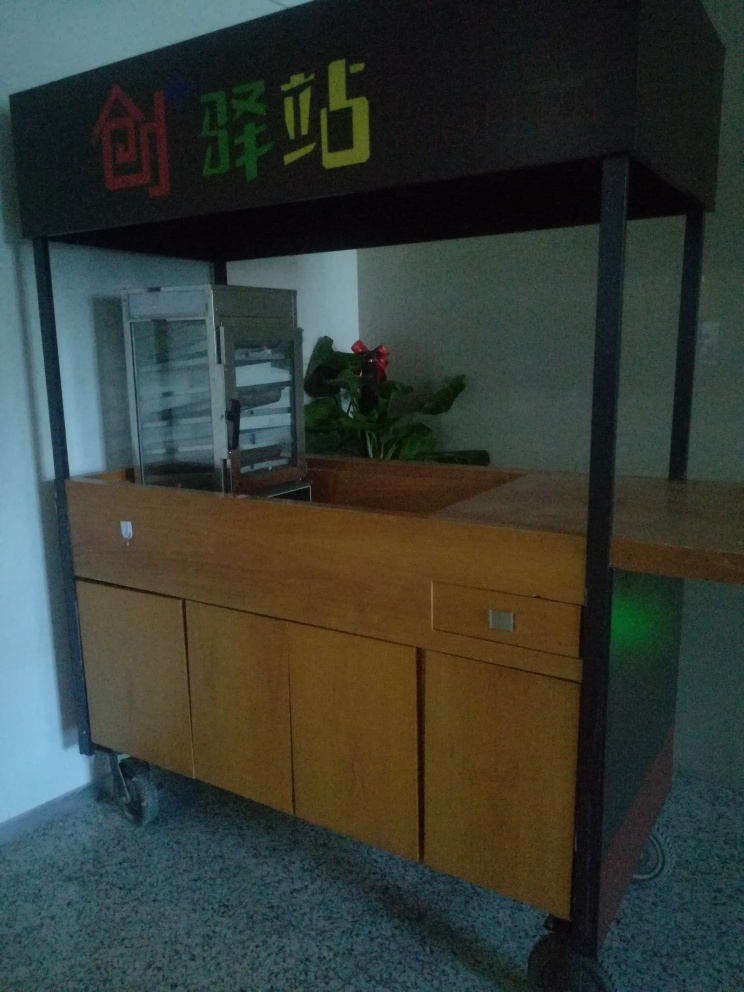What time of day does it seem to be based on the lighting in the image? The lighting in the image suggests it might be early morning or late afternoon, as the natural light is not very bright and has a soft quality to it. There is an absence of strong shadows or harsh light that would indicate a time when the sun is at its peak. 